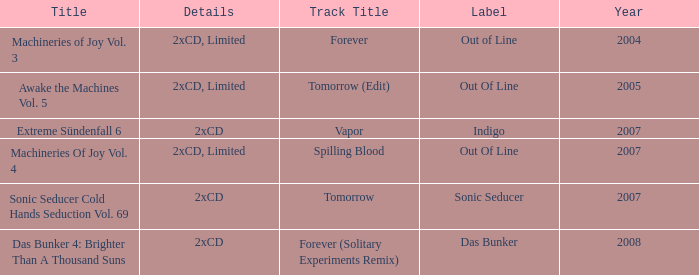Which identifier possesses a year beyond 2004, a 2xcd aspect, and the name sonic seducer cold hands seduction vol. 69? Sonic Seducer. 